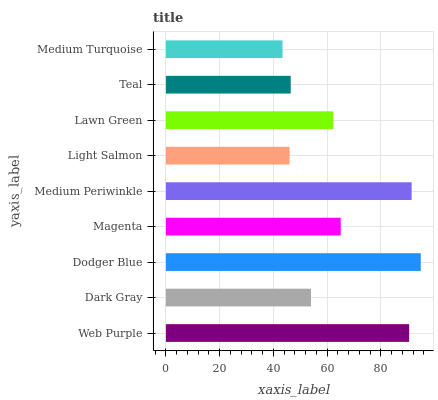Is Medium Turquoise the minimum?
Answer yes or no. Yes. Is Dodger Blue the maximum?
Answer yes or no. Yes. Is Dark Gray the minimum?
Answer yes or no. No. Is Dark Gray the maximum?
Answer yes or no. No. Is Web Purple greater than Dark Gray?
Answer yes or no. Yes. Is Dark Gray less than Web Purple?
Answer yes or no. Yes. Is Dark Gray greater than Web Purple?
Answer yes or no. No. Is Web Purple less than Dark Gray?
Answer yes or no. No. Is Lawn Green the high median?
Answer yes or no. Yes. Is Lawn Green the low median?
Answer yes or no. Yes. Is Teal the high median?
Answer yes or no. No. Is Light Salmon the low median?
Answer yes or no. No. 